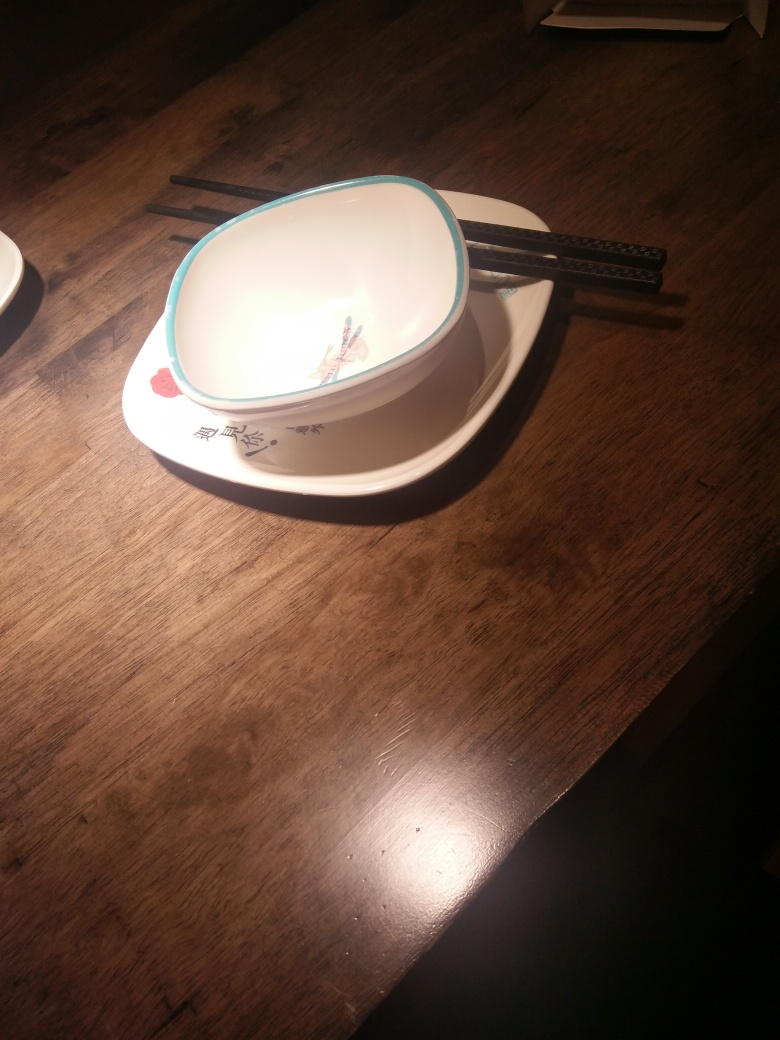What is the color of the image? The image displays a white dish with a light blue rim placed on a dark wooden table. The dish has a subtle floral design, primarily in red and green tones. The chopsticks resting on the dish are black, and there's a warm, yellowish hue from the overhead lighting. 